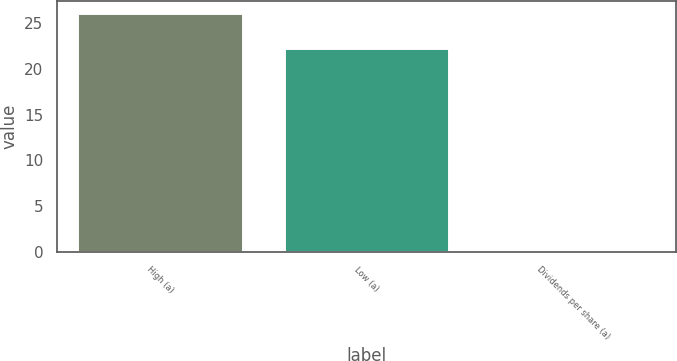<chart> <loc_0><loc_0><loc_500><loc_500><bar_chart><fcel>High (a)<fcel>Low (a)<fcel>Dividends per share (a)<nl><fcel>26.08<fcel>22.32<fcel>0.05<nl></chart> 